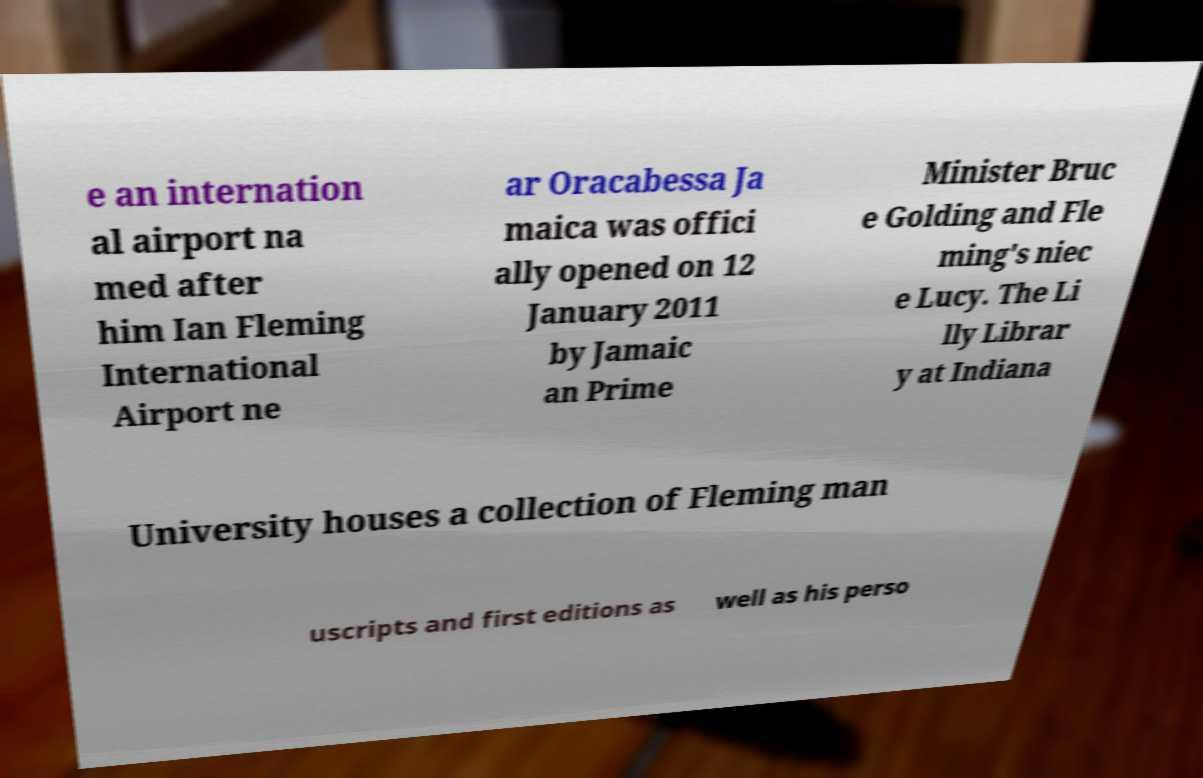Can you read and provide the text displayed in the image?This photo seems to have some interesting text. Can you extract and type it out for me? e an internation al airport na med after him Ian Fleming International Airport ne ar Oracabessa Ja maica was offici ally opened on 12 January 2011 by Jamaic an Prime Minister Bruc e Golding and Fle ming's niec e Lucy. The Li lly Librar y at Indiana University houses a collection of Fleming man uscripts and first editions as well as his perso 